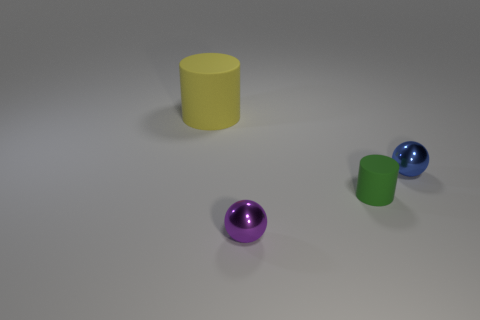What material is the tiny green cylinder?
Ensure brevity in your answer.  Rubber. Are the tiny sphere behind the green cylinder and the big yellow thing made of the same material?
Make the answer very short. No. There is a matte object behind the blue metallic thing; is it the same size as the green rubber cylinder?
Provide a succinct answer. No. Is the large cylinder that is on the left side of the green matte cylinder made of the same material as the cylinder that is in front of the tiny blue object?
Make the answer very short. Yes. Are there any cylinders that have the same size as the purple metallic ball?
Give a very brief answer. Yes. There is a tiny metal object right of the shiny ball that is in front of the small thing that is on the right side of the tiny rubber thing; what is its shape?
Your answer should be compact. Sphere. Are there more yellow cylinders that are behind the small matte cylinder than big blue metallic blocks?
Keep it short and to the point. Yes. Is there another object of the same shape as the blue metal thing?
Offer a terse response. Yes. Are the small purple sphere and the cylinder that is behind the green rubber cylinder made of the same material?
Your answer should be very brief. No. What is the color of the large object?
Your answer should be very brief. Yellow. 